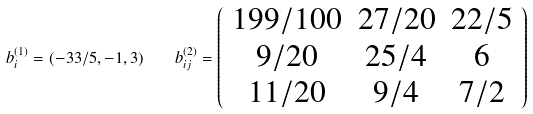<formula> <loc_0><loc_0><loc_500><loc_500>b _ { i } ^ { ( 1 ) } = ( - 3 3 / 5 , - 1 , 3 ) \quad b _ { i j } ^ { ( 2 ) } = \left ( \begin{array} { c c c } 1 9 9 / 1 0 0 & 2 7 / 2 0 & 2 2 / 5 \\ 9 / 2 0 & 2 5 / 4 & 6 \\ 1 1 / 2 0 & 9 / 4 & 7 / 2 \end{array} \right )</formula> 